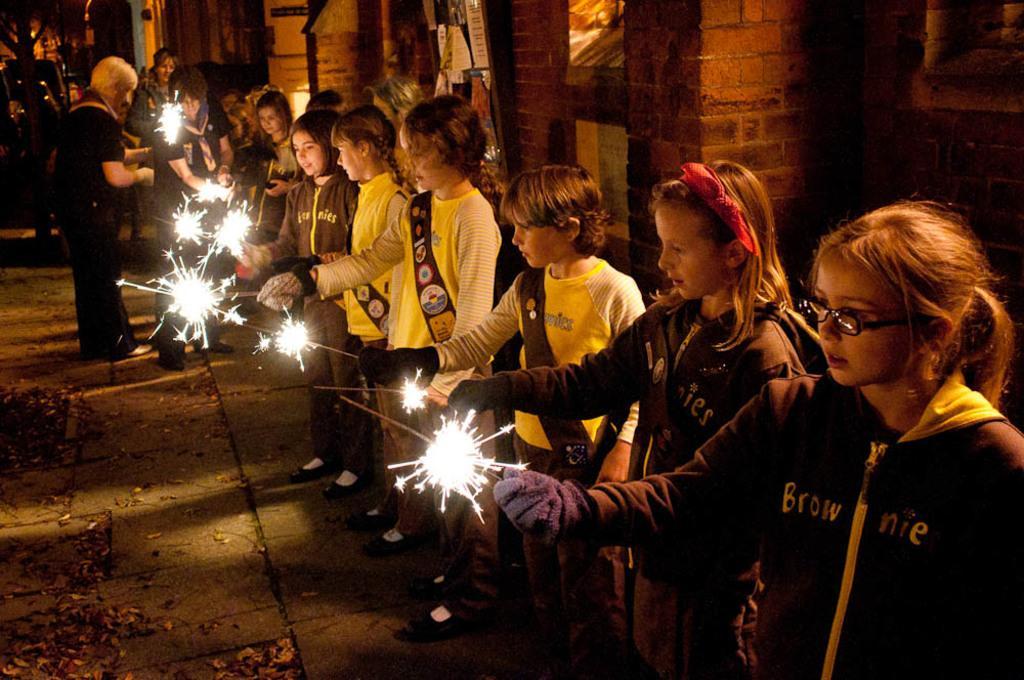How would you summarize this image in a sentence or two? In this image I can see number of children and persons are standing and holding fireworks in their hands. In the background I can see a building and a tree. 